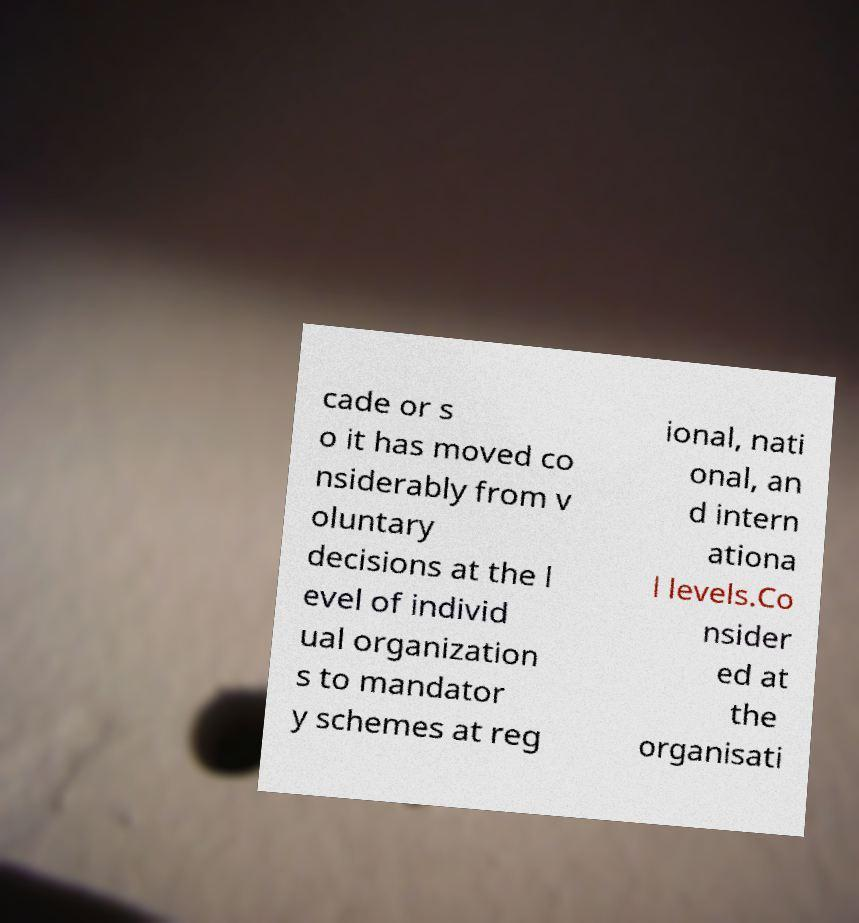Please identify and transcribe the text found in this image. cade or s o it has moved co nsiderably from v oluntary decisions at the l evel of individ ual organization s to mandator y schemes at reg ional, nati onal, an d intern ationa l levels.Co nsider ed at the organisati 